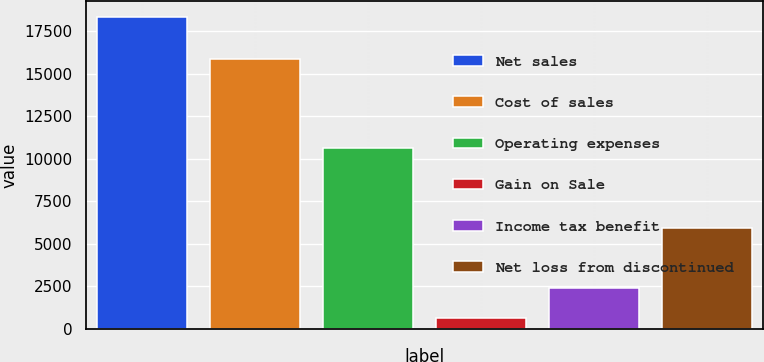Convert chart to OTSL. <chart><loc_0><loc_0><loc_500><loc_500><bar_chart><fcel>Net sales<fcel>Cost of sales<fcel>Operating expenses<fcel>Gain on Sale<fcel>Income tax benefit<fcel>Net loss from discontinued<nl><fcel>18334<fcel>15841<fcel>10650<fcel>643<fcel>2412.1<fcel>5953<nl></chart> 